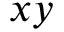<formula> <loc_0><loc_0><loc_500><loc_500>x y</formula> 